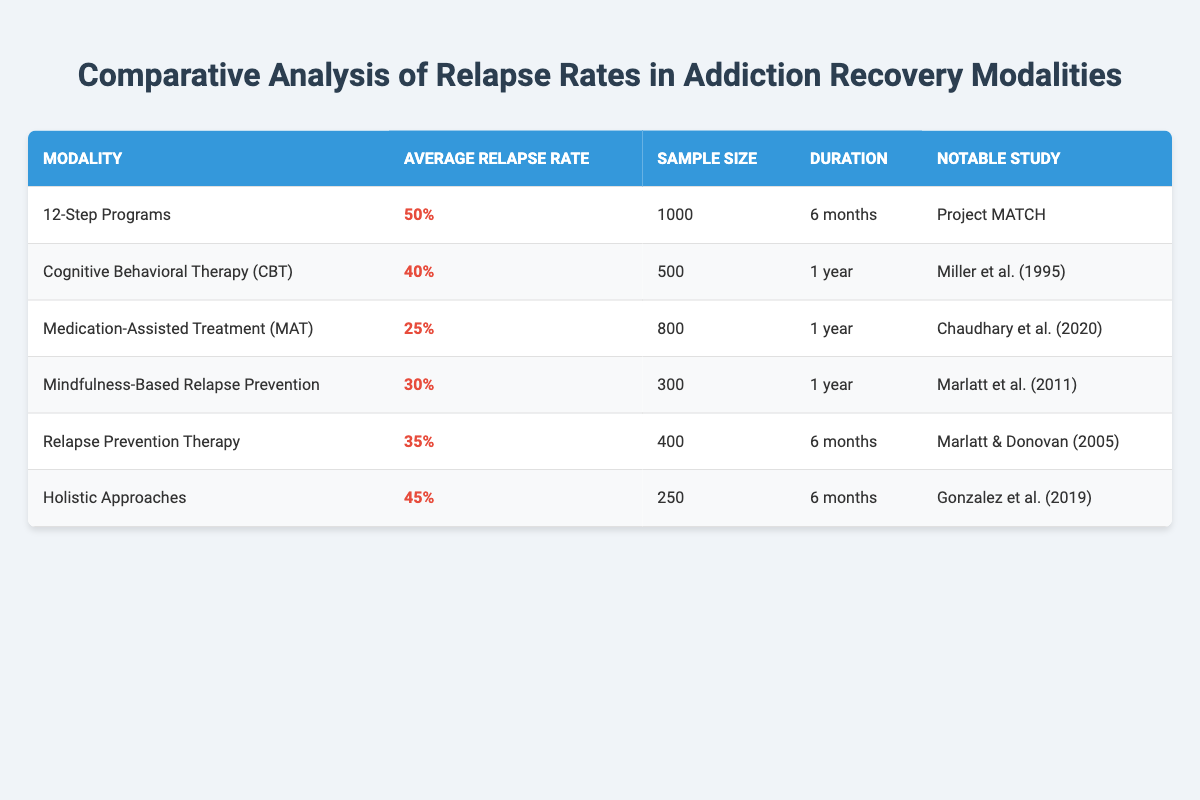What is the average relapse rate for Medication-Assisted Treatment (MAT)? The table lists the average relapse rate for Medication-Assisted Treatment (MAT) specifically as 25%.
Answer: 25% Which modality has the highest average relapse rate according to the table? The table indicates that 12-Step Programs have the highest average relapse rate at 50%.
Answer: 12-Step Programs Is the sample size for Holistic Approaches greater than 400? The sample size for Holistic Approaches is 250, which is less than 400.
Answer: No What is the difference in relapse rates between Cognitive Behavioral Therapy (CBT) and Mindfulness-Based Relapse Prevention? The average relapse rate for CBT is 40%, and for Mindfulness-Based Relapse Prevention, it is 30%. The difference is 40% - 30% = 10%.
Answer: 10% What is the average sample size across all modalities mentioned in the table? To find the average sample size: sum the sample sizes (1000 + 500 + 800 + 300 + 400 + 250 = 3250) and divide by the number of modalities (6). Hence, the average sample size is 3250 / 6 = 541.67, which we round to approximately 542.
Answer: 542 Is there a modality that shows a relapse rate below 30%? Yes, the table shows that Medication-Assisted Treatment (MAT) has a relapse rate of 25%, which is below 30%.
Answer: Yes Which modalities have a sample size greater than 500? The modalities with a sample size greater than 500 are 12-Step Programs (1000) and Medication-Assisted Treatment (MAT) (800).
Answer: 12-Step Programs, Medication-Assisted Treatment (MAT) What percentage of relapse rates fall into the range of 30% to 40%? The modalities within this range are Cognitive Behavioral Therapy (CBT) (40%), and Mindfulness-Based Relapse Prevention (30%), which gives us a total of 2 modalities. The percentage of modalities that fall into this range is 2 out of 6, leading to (2/6 * 100) = 33.33%.
Answer: 33.33% 